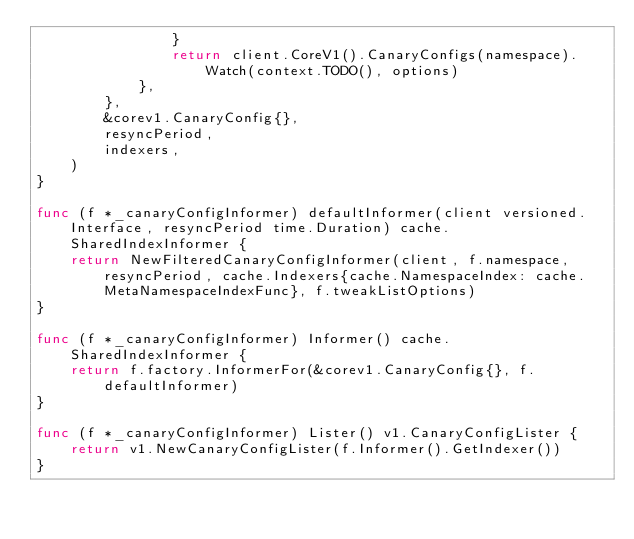<code> <loc_0><loc_0><loc_500><loc_500><_Go_>				}
				return client.CoreV1().CanaryConfigs(namespace).Watch(context.TODO(), options)
			},
		},
		&corev1.CanaryConfig{},
		resyncPeriod,
		indexers,
	)
}

func (f *_canaryConfigInformer) defaultInformer(client versioned.Interface, resyncPeriod time.Duration) cache.SharedIndexInformer {
	return NewFilteredCanaryConfigInformer(client, f.namespace, resyncPeriod, cache.Indexers{cache.NamespaceIndex: cache.MetaNamespaceIndexFunc}, f.tweakListOptions)
}

func (f *_canaryConfigInformer) Informer() cache.SharedIndexInformer {
	return f.factory.InformerFor(&corev1.CanaryConfig{}, f.defaultInformer)
}

func (f *_canaryConfigInformer) Lister() v1.CanaryConfigLister {
	return v1.NewCanaryConfigLister(f.Informer().GetIndexer())
}
</code> 